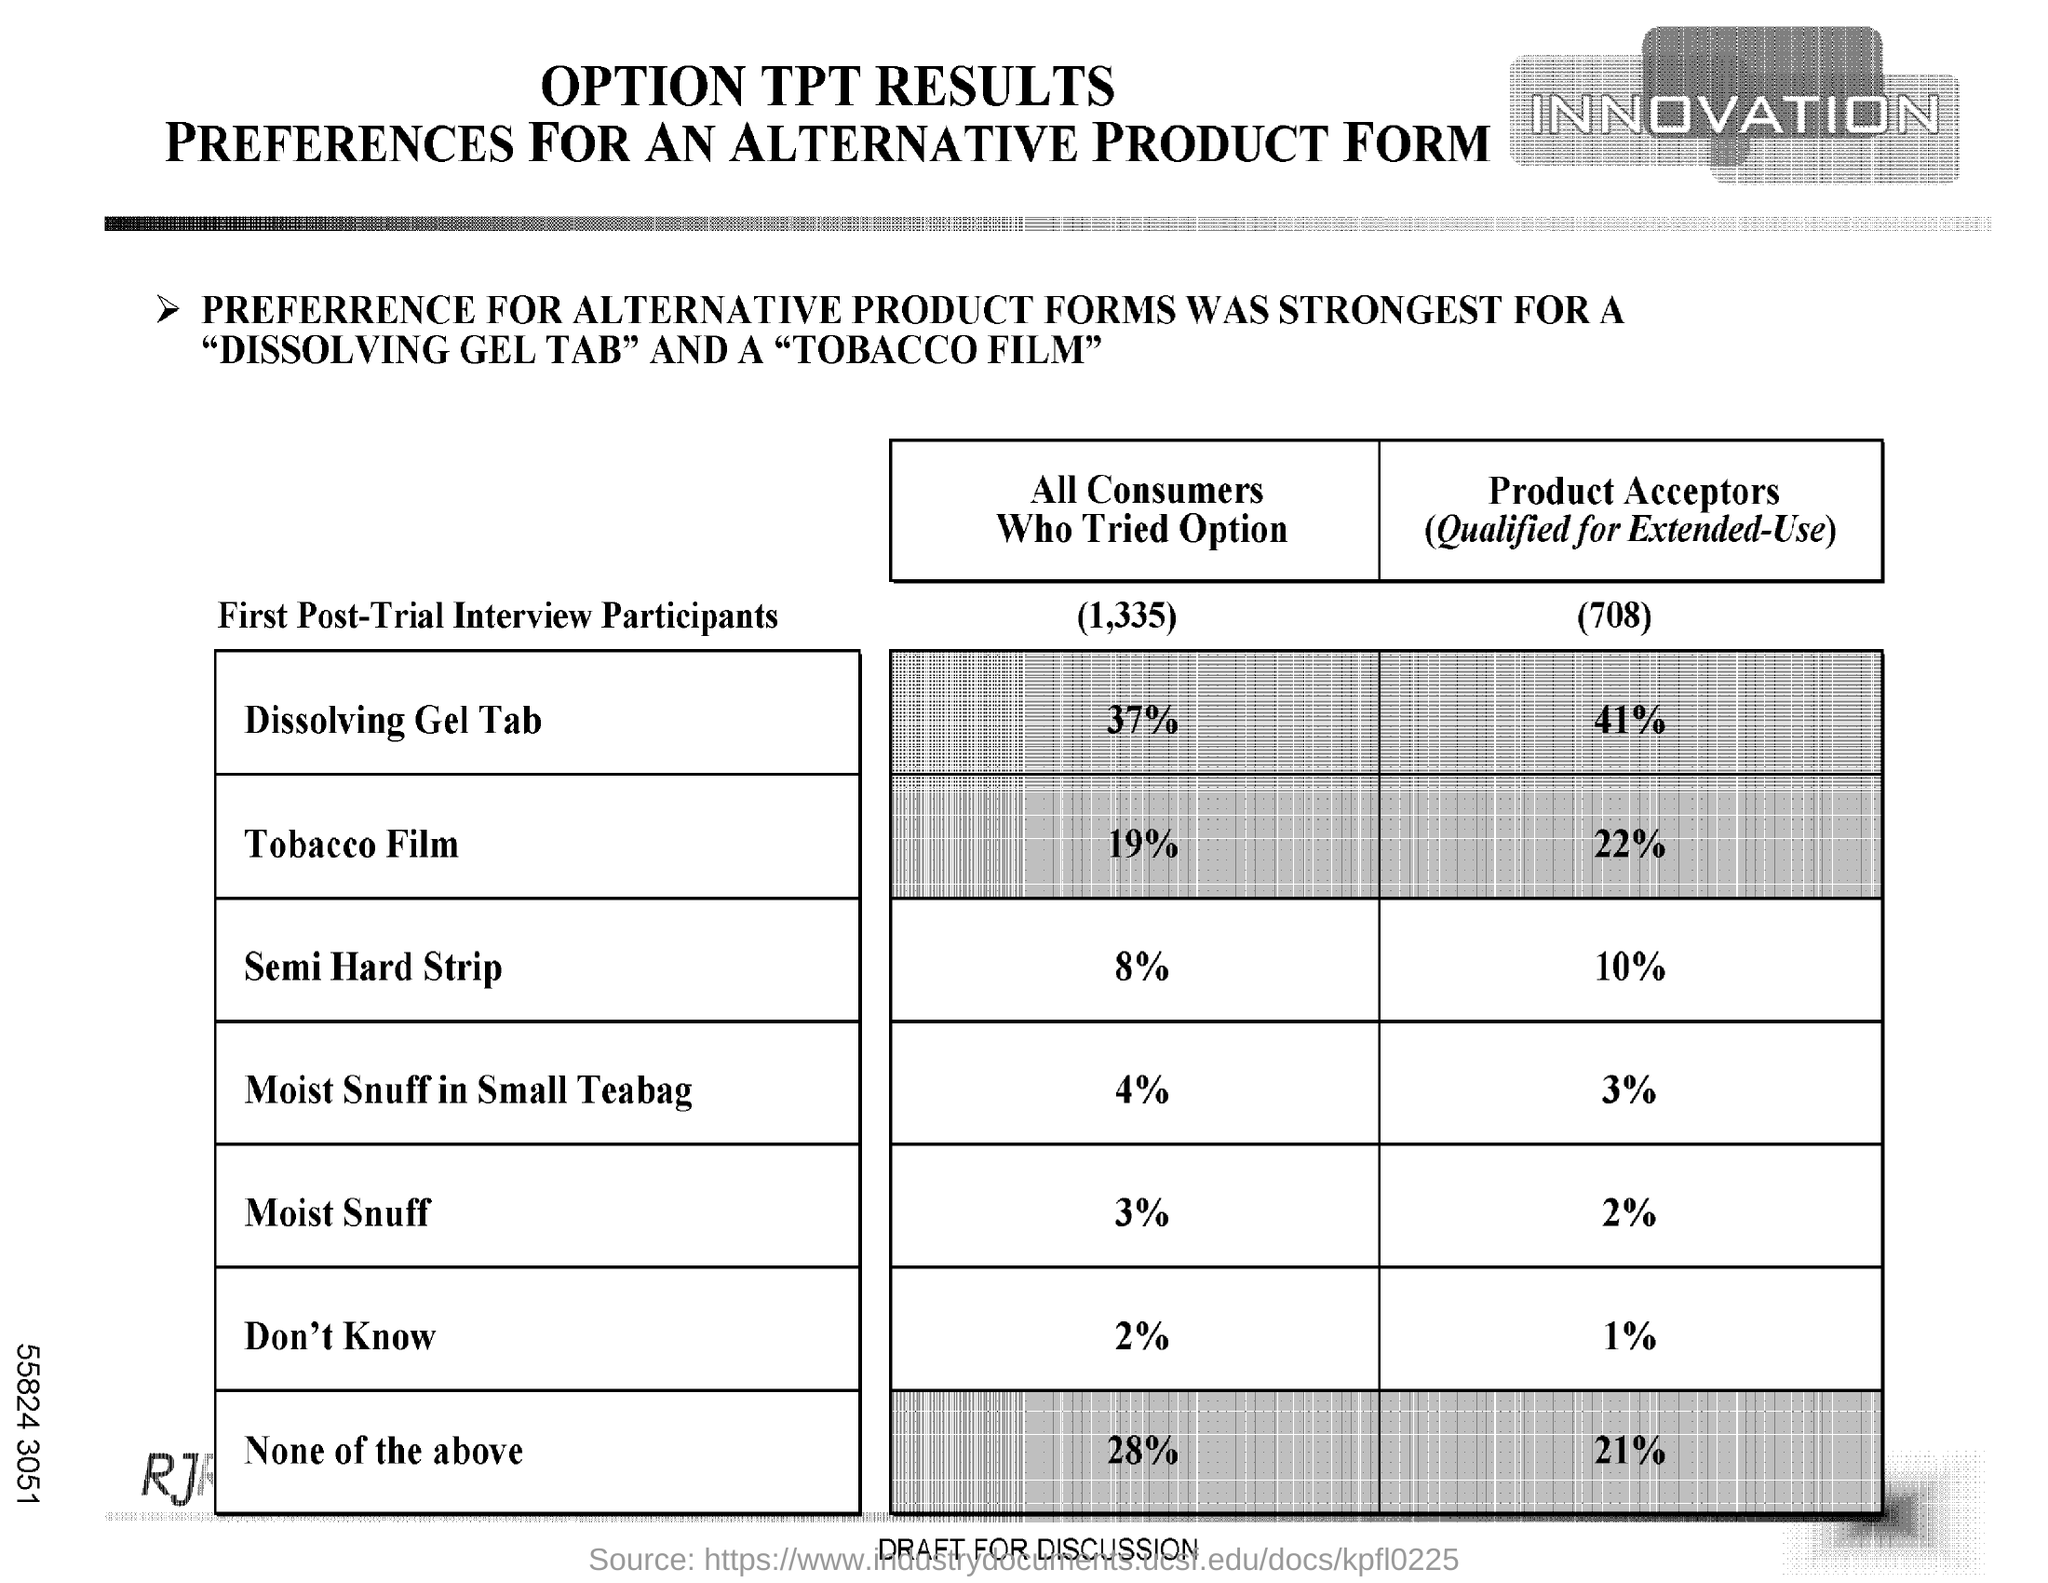Draw attention to some important aspects in this diagram. A total of 19% of all consumers surveyed reported having tried the tobacco film option. According to our survey, 8% of all consumers have tried the option of "Semi Hard Strip. 